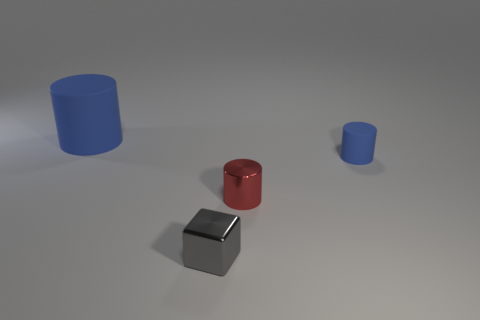Subtract all tiny cylinders. How many cylinders are left? 1 Add 1 big blue shiny blocks. How many objects exist? 5 Subtract all red cylinders. How many cylinders are left? 2 Subtract all blocks. How many objects are left? 3 Subtract 1 cylinders. How many cylinders are left? 2 Subtract all green blocks. Subtract all blue cylinders. How many blocks are left? 1 Subtract all green cubes. How many red cylinders are left? 1 Subtract all tiny metallic objects. Subtract all matte cylinders. How many objects are left? 0 Add 2 red cylinders. How many red cylinders are left? 3 Add 1 red metal cylinders. How many red metal cylinders exist? 2 